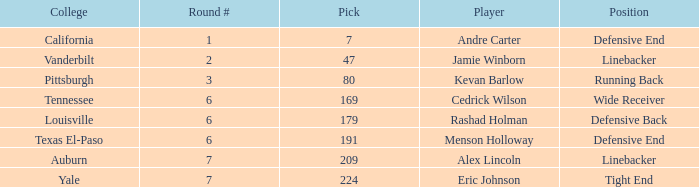Which pick came from Pittsburgh? 1.0. 